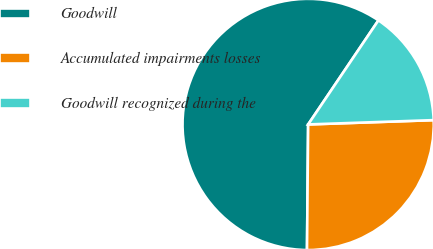Convert chart to OTSL. <chart><loc_0><loc_0><loc_500><loc_500><pie_chart><fcel>Goodwill<fcel>Accumulated impairments losses<fcel>Goodwill recognized during the<nl><fcel>59.3%<fcel>25.69%<fcel>15.0%<nl></chart> 